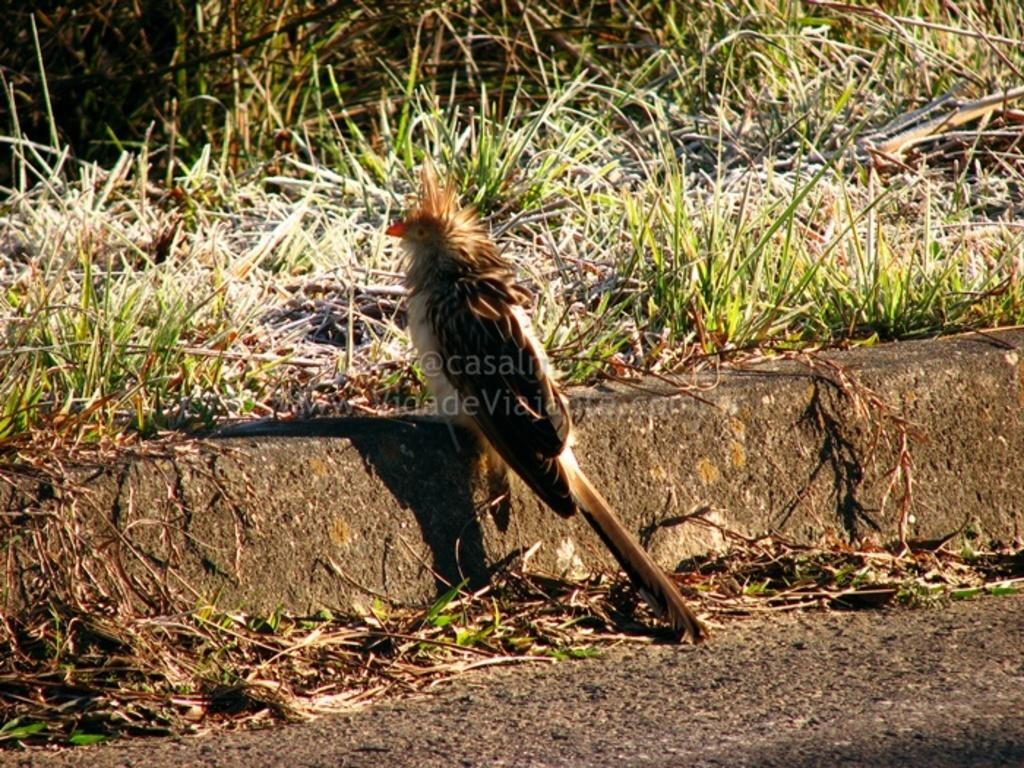What type of vegetation can be seen in the image? There is grass in the image. What type of animal is present in the image? There is a bird in the image. Can you describe the watermark in the image? There is a watermark in the middle portion of the image. What type of discovery was made by the bird in the image? There is no indication of a discovery in the image; it simply features a bird and grass. What is the bird's nose like in the image? Birds do not have noses like humans, so this question cannot be answered based on the image. 